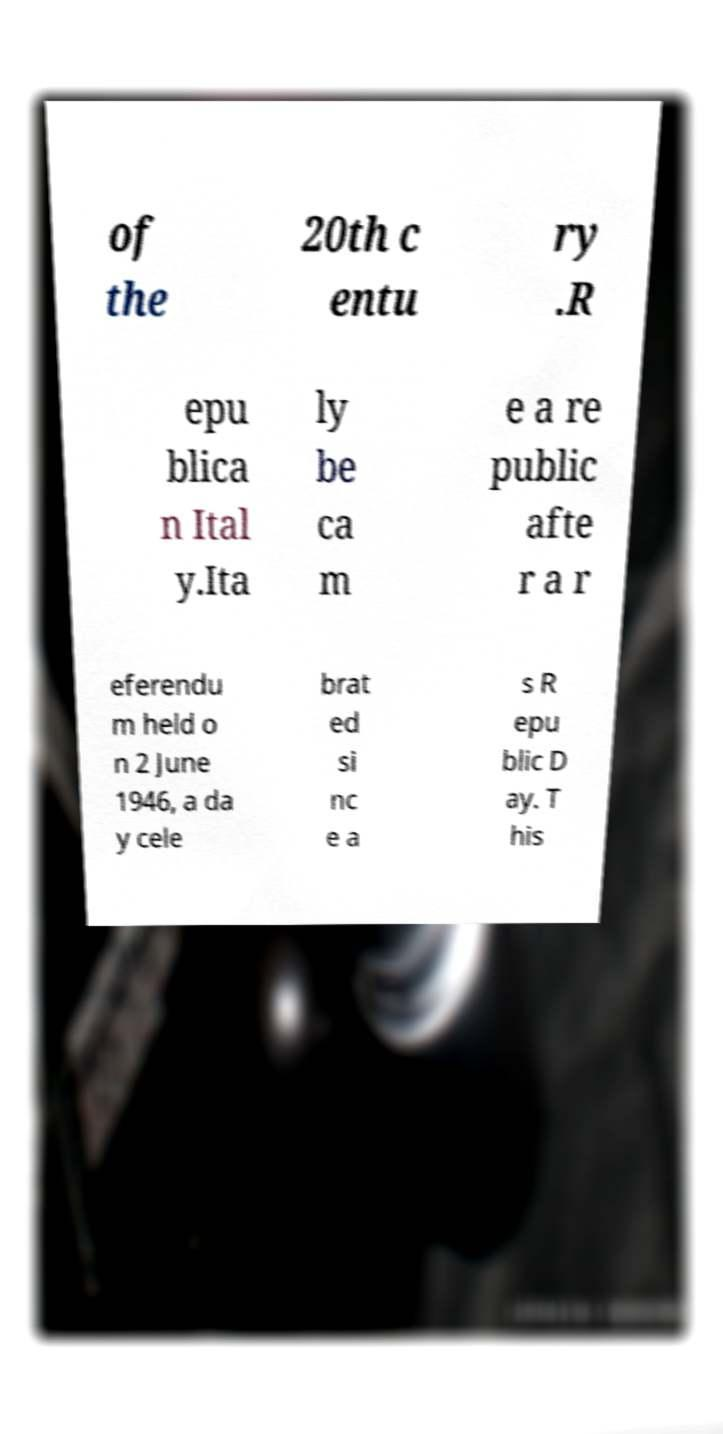Could you extract and type out the text from this image? of the 20th c entu ry .R epu blica n Ital y.Ita ly be ca m e a re public afte r a r eferendu m held o n 2 June 1946, a da y cele brat ed si nc e a s R epu blic D ay. T his 